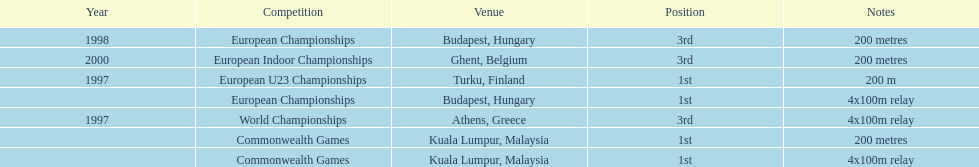What was the only event won in belgium? European Indoor Championships. 